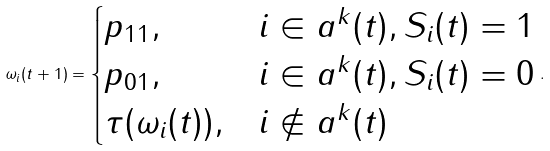Convert formula to latex. <formula><loc_0><loc_0><loc_500><loc_500>\omega _ { i } ( t + 1 ) = \begin{cases} p _ { 1 1 } , & i \in a ^ { k } ( t ) , S _ { i } ( t ) = 1 \\ p _ { 0 1 } , & i \in a ^ { k } ( t ) , S _ { i } ( t ) = 0 \\ \tau ( \omega _ { i } ( t ) ) , & i \not \in a ^ { k } ( t ) \end{cases} .</formula> 